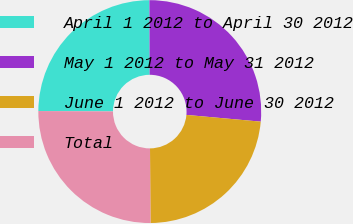<chart> <loc_0><loc_0><loc_500><loc_500><pie_chart><fcel>April 1 2012 to April 30 2012<fcel>May 1 2012 to May 31 2012<fcel>June 1 2012 to June 30 2012<fcel>Total<nl><fcel>24.88%<fcel>26.48%<fcel>23.46%<fcel>25.18%<nl></chart> 